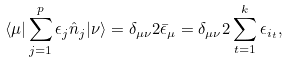Convert formula to latex. <formula><loc_0><loc_0><loc_500><loc_500>\langle \mu | \sum _ { j = 1 } ^ { p } \epsilon _ { j } \hat { n } _ { j } | \nu \rangle = \delta _ { \mu \nu } 2 \bar { \epsilon } _ { \mu } = \delta _ { \mu \nu } 2 \sum _ { t = 1 } ^ { k } \epsilon _ { i _ { t } } ,</formula> 